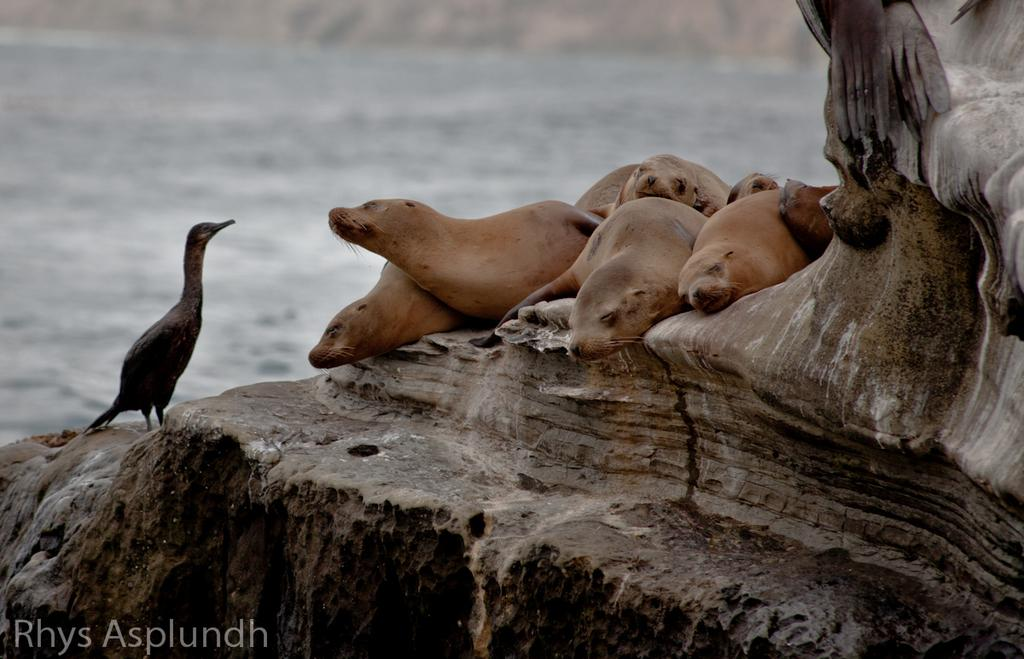What animals are present in the image? There are seals in the image. What other type of animal can be seen in the image? There is a bird in the image. Where is the bird located in the image? The bird is on a rock. Can you describe the background of the image? The background of the image is blurred. Is there any additional marking or feature in the image? Yes, there is a watermark in the left bottom corner of the image. What type of cloud can be seen in the image? There are no clouds visible in the image. Is there a car present in the image? No, there is no car present in the image. 